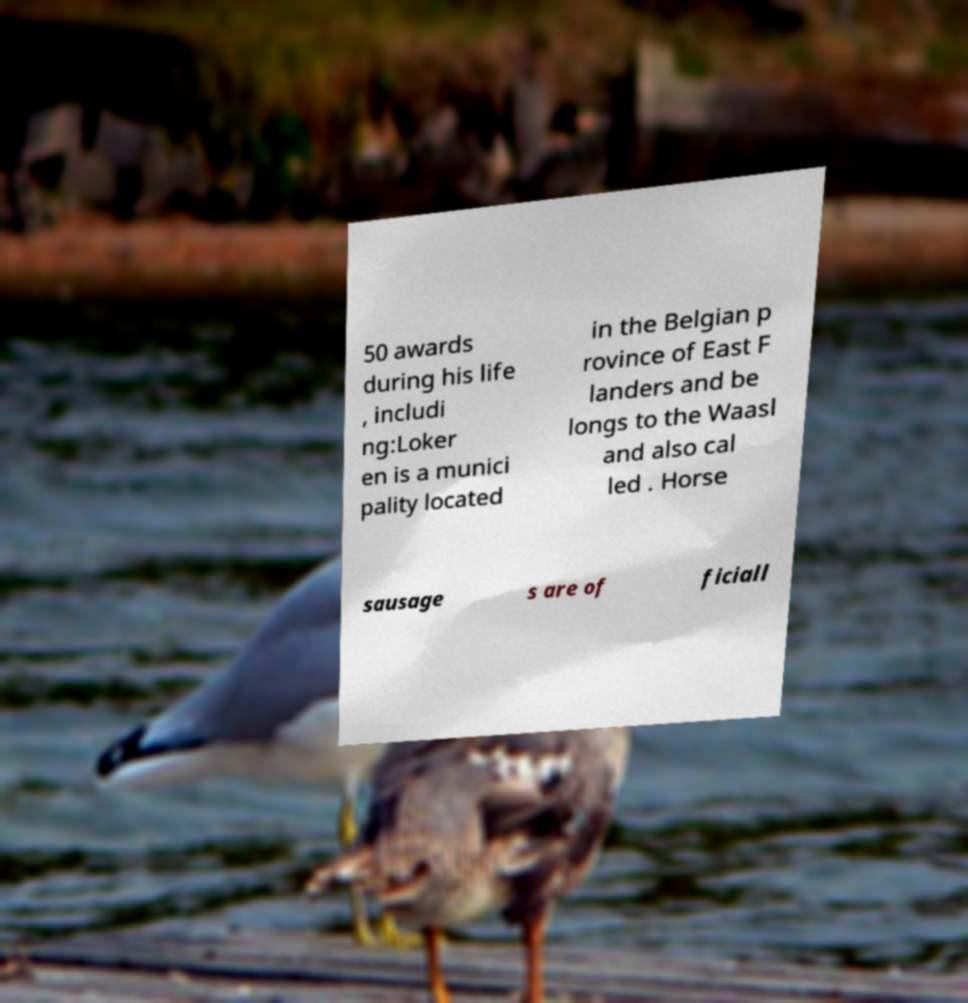Can you accurately transcribe the text from the provided image for me? 50 awards during his life , includi ng:Loker en is a munici pality located in the Belgian p rovince of East F landers and be longs to the Waasl and also cal led . Horse sausage s are of ficiall 